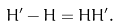<formula> <loc_0><loc_0><loc_500><loc_500>H ^ { \prime } - H = H H ^ { \prime } .</formula> 